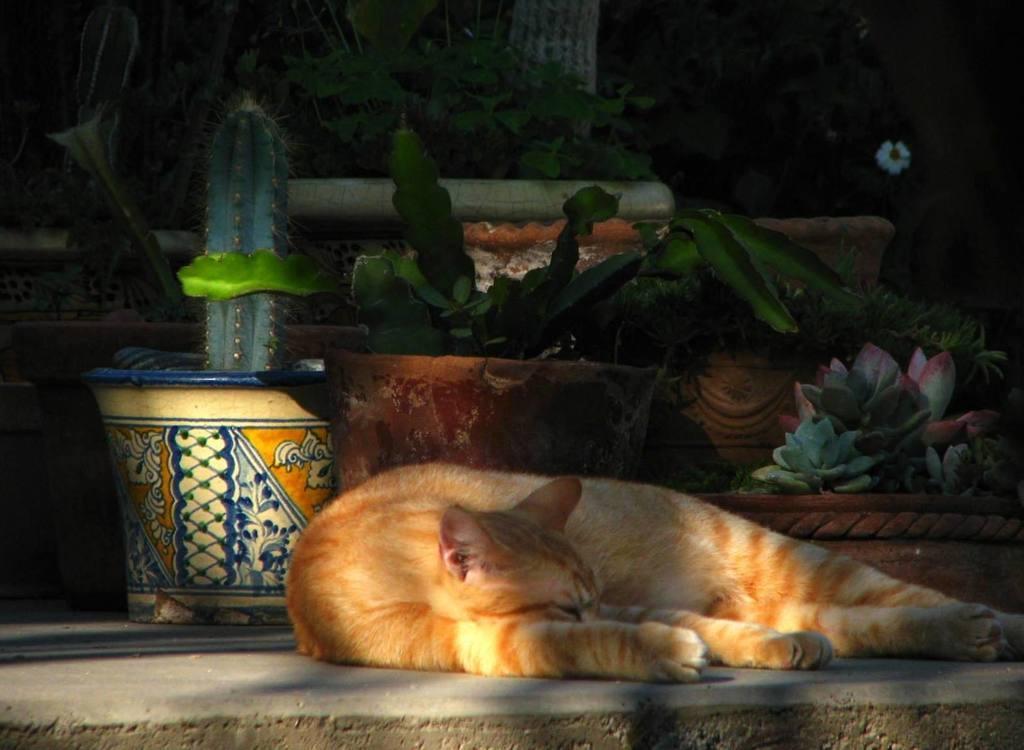How would you summarize this image in a sentence or two? This picture shows a cat laying on the ground. It is white and brown in color and we see few plants in the pots and we see flowers. 